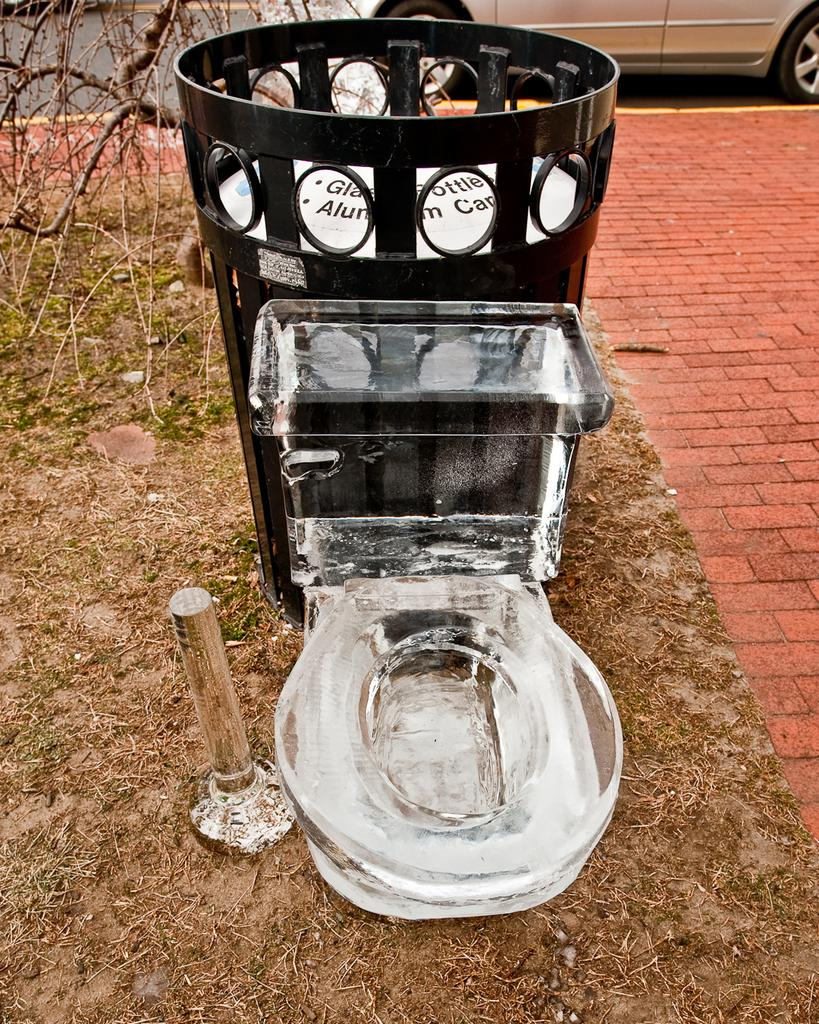<image>
Offer a succinct explanation of the picture presented. an ice sculpture of a toilet next to a garbage bin reading Glass Bottles 